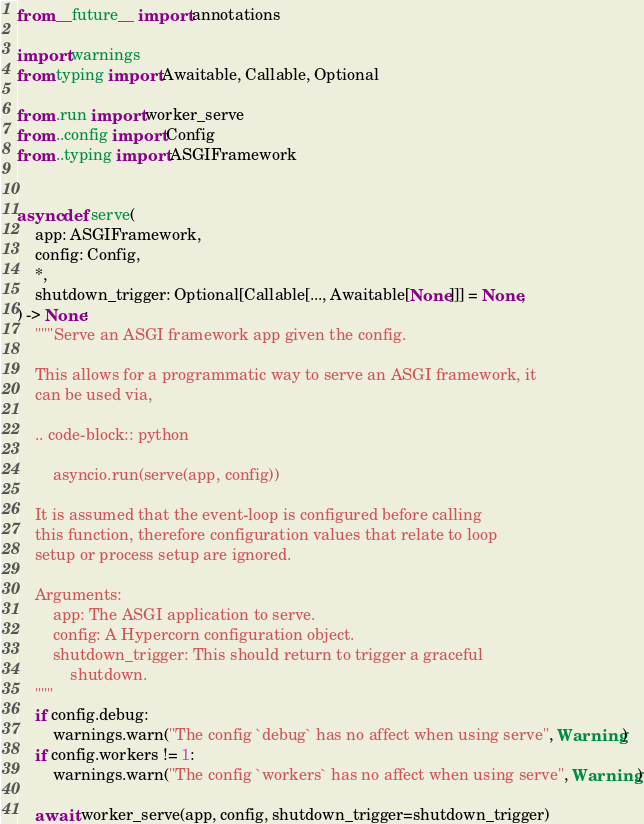<code> <loc_0><loc_0><loc_500><loc_500><_Python_>from __future__ import annotations

import warnings
from typing import Awaitable, Callable, Optional

from .run import worker_serve
from ..config import Config
from ..typing import ASGIFramework


async def serve(
    app: ASGIFramework,
    config: Config,
    *,
    shutdown_trigger: Optional[Callable[..., Awaitable[None]]] = None,
) -> None:
    """Serve an ASGI framework app given the config.

    This allows for a programmatic way to serve an ASGI framework, it
    can be used via,

    .. code-block:: python

        asyncio.run(serve(app, config))

    It is assumed that the event-loop is configured before calling
    this function, therefore configuration values that relate to loop
    setup or process setup are ignored.

    Arguments:
        app: The ASGI application to serve.
        config: A Hypercorn configuration object.
        shutdown_trigger: This should return to trigger a graceful
            shutdown.
    """
    if config.debug:
        warnings.warn("The config `debug` has no affect when using serve", Warning)
    if config.workers != 1:
        warnings.warn("The config `workers` has no affect when using serve", Warning)

    await worker_serve(app, config, shutdown_trigger=shutdown_trigger)
</code> 